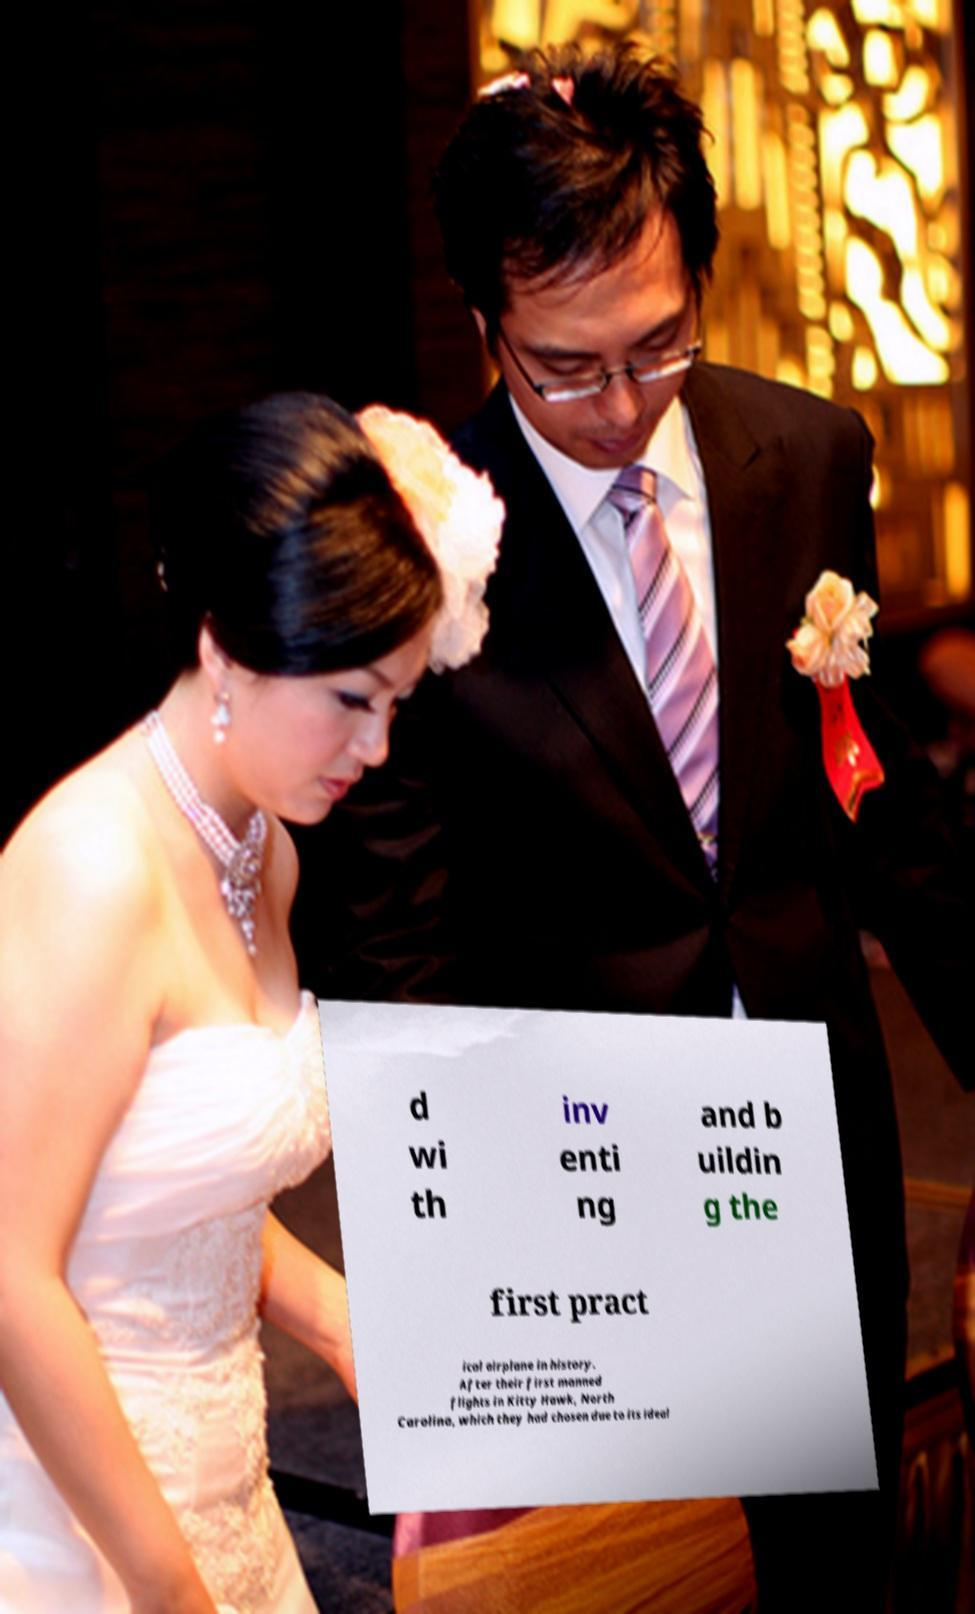Could you assist in decoding the text presented in this image and type it out clearly? d wi th inv enti ng and b uildin g the first pract ical airplane in history. After their first manned flights in Kitty Hawk, North Carolina, which they had chosen due to its ideal 